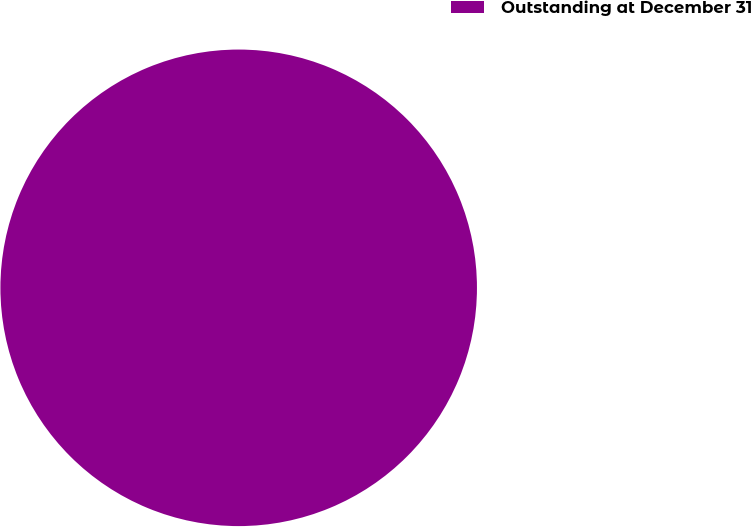Convert chart. <chart><loc_0><loc_0><loc_500><loc_500><pie_chart><fcel>Outstanding at December 31<nl><fcel>100.0%<nl></chart> 